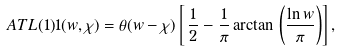Convert formula to latex. <formula><loc_0><loc_0><loc_500><loc_500>\ A T L { ( 1 ) } { 1 } ( w , \chi ) = \theta ( w - \chi ) \left [ \, \frac { 1 } { 2 } - \frac { 1 } { \pi } \arctan \, \left ( \frac { \ln w } { \pi } \right ) \right ] ,</formula> 